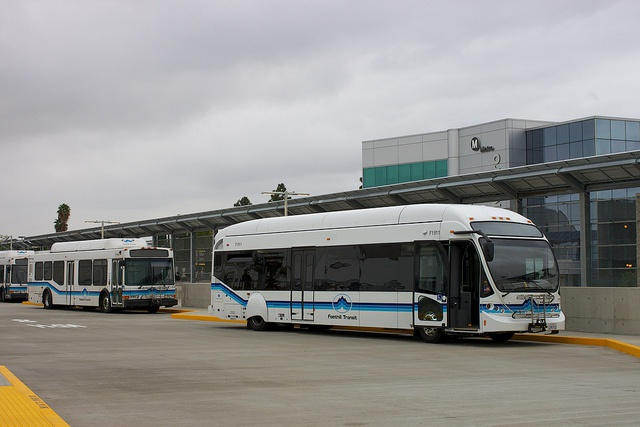Describe the objects in this image and their specific colors. I can see bus in lightgray, black, darkgray, and gray tones, bus in lightgray, black, darkgray, and gray tones, and bus in lightgray, black, darkgray, and gray tones in this image. 